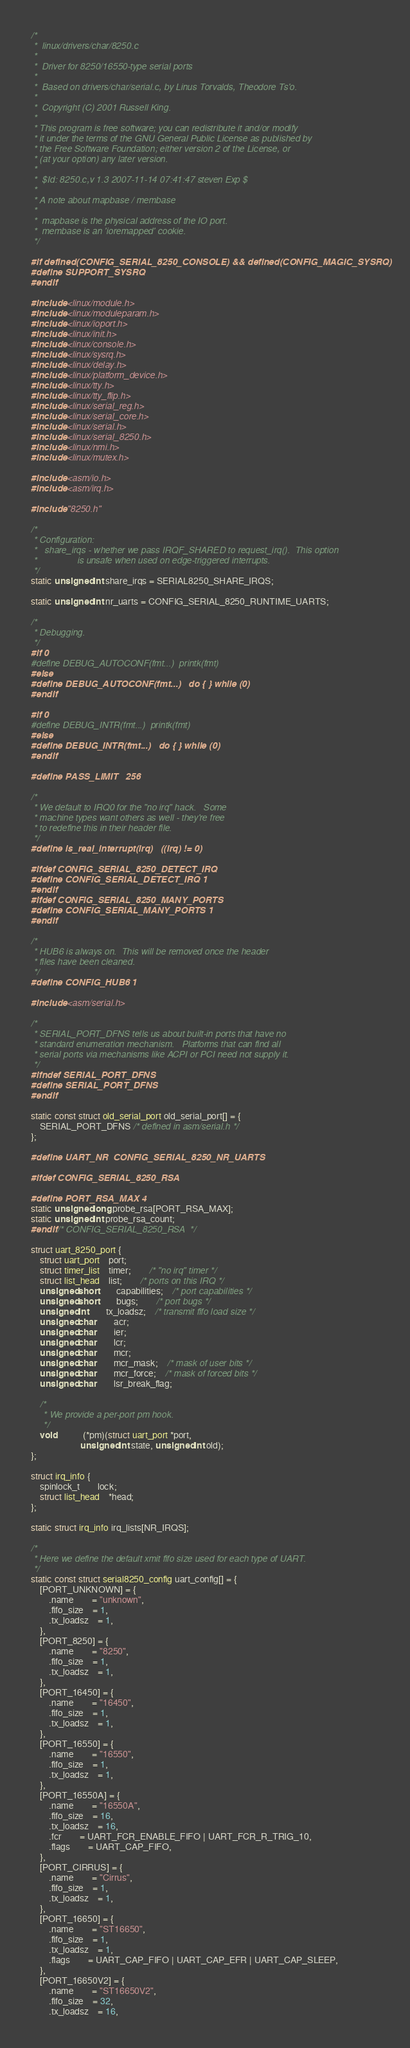<code> <loc_0><loc_0><loc_500><loc_500><_C_>/*
 *  linux/drivers/char/8250.c
 *
 *  Driver for 8250/16550-type serial ports
 *
 *  Based on drivers/char/serial.c, by Linus Torvalds, Theodore Ts'o.
 *
 *  Copyright (C) 2001 Russell King.
 *
 * This program is free software; you can redistribute it and/or modify
 * it under the terms of the GNU General Public License as published by
 * the Free Software Foundation; either version 2 of the License, or
 * (at your option) any later version.
 *
 *  $Id: 8250.c,v 1.3 2007-11-14 07:41:47 steven Exp $
 *
 * A note about mapbase / membase
 *
 *  mapbase is the physical address of the IO port.
 *  membase is an 'ioremapped' cookie.
 */

#if defined(CONFIG_SERIAL_8250_CONSOLE) && defined(CONFIG_MAGIC_SYSRQ)
#define SUPPORT_SYSRQ
#endif

#include <linux/module.h>
#include <linux/moduleparam.h>
#include <linux/ioport.h>
#include <linux/init.h>
#include <linux/console.h>
#include <linux/sysrq.h>
#include <linux/delay.h>
#include <linux/platform_device.h>
#include <linux/tty.h>
#include <linux/tty_flip.h>
#include <linux/serial_reg.h>
#include <linux/serial_core.h>
#include <linux/serial.h>
#include <linux/serial_8250.h>
#include <linux/nmi.h>
#include <linux/mutex.h>

#include <asm/io.h>
#include <asm/irq.h>

#include "8250.h"

/*
 * Configuration:
 *   share_irqs - whether we pass IRQF_SHARED to request_irq().  This option
 *                is unsafe when used on edge-triggered interrupts.
 */
static unsigned int share_irqs = SERIAL8250_SHARE_IRQS;

static unsigned int nr_uarts = CONFIG_SERIAL_8250_RUNTIME_UARTS;

/*
 * Debugging.
 */
#if 0
#define DEBUG_AUTOCONF(fmt...)	printk(fmt)
#else
#define DEBUG_AUTOCONF(fmt...)	do { } while (0)
#endif

#if 0
#define DEBUG_INTR(fmt...)	printk(fmt)
#else
#define DEBUG_INTR(fmt...)	do { } while (0)
#endif

#define PASS_LIMIT	256

/*
 * We default to IRQ0 for the "no irq" hack.   Some
 * machine types want others as well - they're free
 * to redefine this in their header file.
 */
#define is_real_interrupt(irq)	((irq) != 0)

#ifdef CONFIG_SERIAL_8250_DETECT_IRQ
#define CONFIG_SERIAL_DETECT_IRQ 1
#endif
#ifdef CONFIG_SERIAL_8250_MANY_PORTS
#define CONFIG_SERIAL_MANY_PORTS 1
#endif

/*
 * HUB6 is always on.  This will be removed once the header
 * files have been cleaned.
 */
#define CONFIG_HUB6 1

#include <asm/serial.h>

/*
 * SERIAL_PORT_DFNS tells us about built-in ports that have no
 * standard enumeration mechanism.   Platforms that can find all
 * serial ports via mechanisms like ACPI or PCI need not supply it.
 */
#ifndef SERIAL_PORT_DFNS
#define SERIAL_PORT_DFNS
#endif

static const struct old_serial_port old_serial_port[] = {
	SERIAL_PORT_DFNS /* defined in asm/serial.h */
};

#define UART_NR	CONFIG_SERIAL_8250_NR_UARTS

#ifdef CONFIG_SERIAL_8250_RSA

#define PORT_RSA_MAX 4
static unsigned long probe_rsa[PORT_RSA_MAX];
static unsigned int probe_rsa_count;
#endif /* CONFIG_SERIAL_8250_RSA  */

struct uart_8250_port {
	struct uart_port	port;
	struct timer_list	timer;		/* "no irq" timer */
	struct list_head	list;		/* ports on this IRQ */
	unsigned short		capabilities;	/* port capabilities */
	unsigned short		bugs;		/* port bugs */
	unsigned int		tx_loadsz;	/* transmit fifo load size */
	unsigned char		acr;
	unsigned char		ier;
	unsigned char		lcr;
	unsigned char		mcr;
	unsigned char		mcr_mask;	/* mask of user bits */
	unsigned char		mcr_force;	/* mask of forced bits */
	unsigned char		lsr_break_flag;

	/*
	 * We provide a per-port pm hook.
	 */
	void			(*pm)(struct uart_port *port,
				      unsigned int state, unsigned int old);
};

struct irq_info {
	spinlock_t		lock;
	struct list_head	*head;
};

static struct irq_info irq_lists[NR_IRQS];

/*
 * Here we define the default xmit fifo size used for each type of UART.
 */
static const struct serial8250_config uart_config[] = {
	[PORT_UNKNOWN] = {
		.name		= "unknown",
		.fifo_size	= 1,
		.tx_loadsz	= 1,
	},
	[PORT_8250] = {
		.name		= "8250",
		.fifo_size	= 1,
		.tx_loadsz	= 1,
	},
	[PORT_16450] = {
		.name		= "16450",
		.fifo_size	= 1,
		.tx_loadsz	= 1,
	},
	[PORT_16550] = {
		.name		= "16550",
		.fifo_size	= 1,
		.tx_loadsz	= 1,
	},
	[PORT_16550A] = {
		.name		= "16550A",
		.fifo_size	= 16,
		.tx_loadsz	= 16,
		.fcr		= UART_FCR_ENABLE_FIFO | UART_FCR_R_TRIG_10,
		.flags		= UART_CAP_FIFO,
	},
	[PORT_CIRRUS] = {
		.name		= "Cirrus",
		.fifo_size	= 1,
		.tx_loadsz	= 1,
	},
	[PORT_16650] = {
		.name		= "ST16650",
		.fifo_size	= 1,
		.tx_loadsz	= 1,
		.flags		= UART_CAP_FIFO | UART_CAP_EFR | UART_CAP_SLEEP,
	},
	[PORT_16650V2] = {
		.name		= "ST16650V2",
		.fifo_size	= 32,
		.tx_loadsz	= 16,</code> 